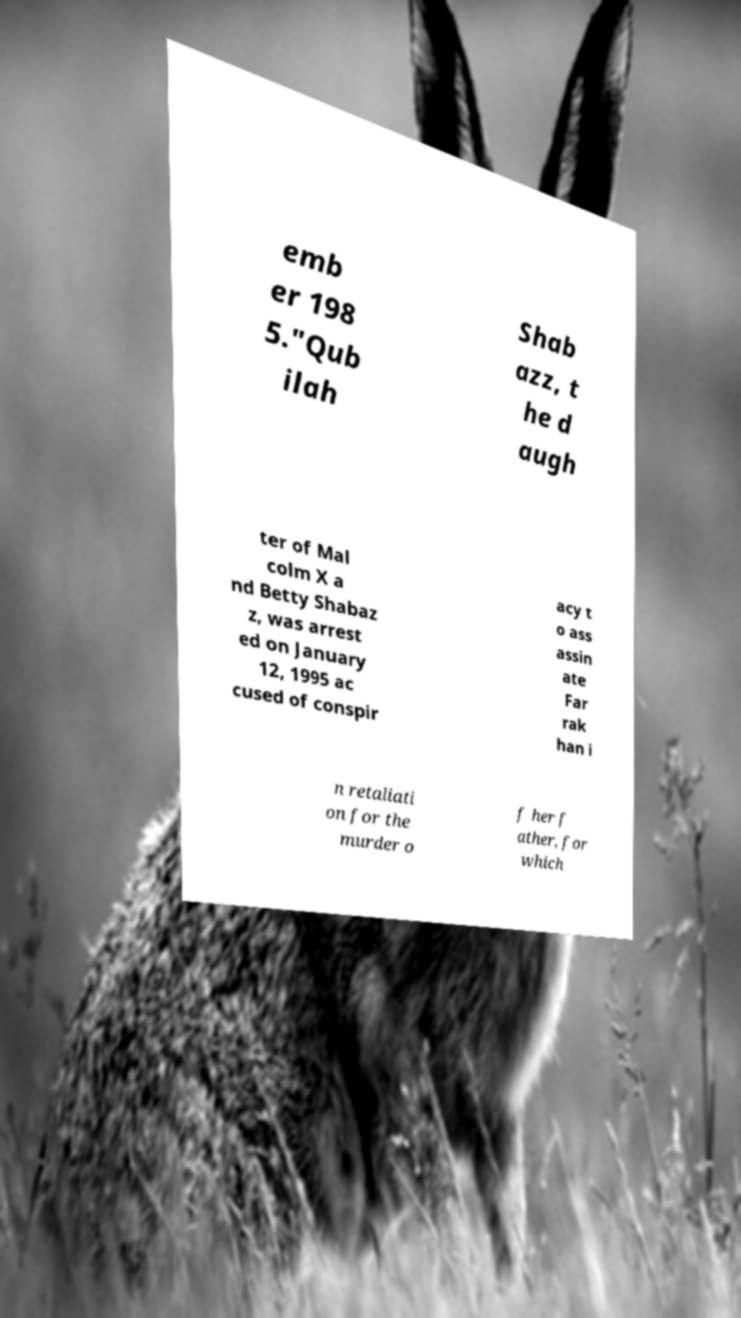There's text embedded in this image that I need extracted. Can you transcribe it verbatim? emb er 198 5."Qub ilah Shab azz, t he d augh ter of Mal colm X a nd Betty Shabaz z, was arrest ed on January 12, 1995 ac cused of conspir acy t o ass assin ate Far rak han i n retaliati on for the murder o f her f ather, for which 